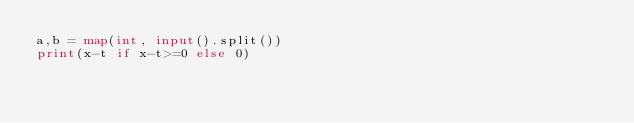<code> <loc_0><loc_0><loc_500><loc_500><_Python_>a,b = map(int, input().split())
print(x-t if x-t>=0 else 0)</code> 